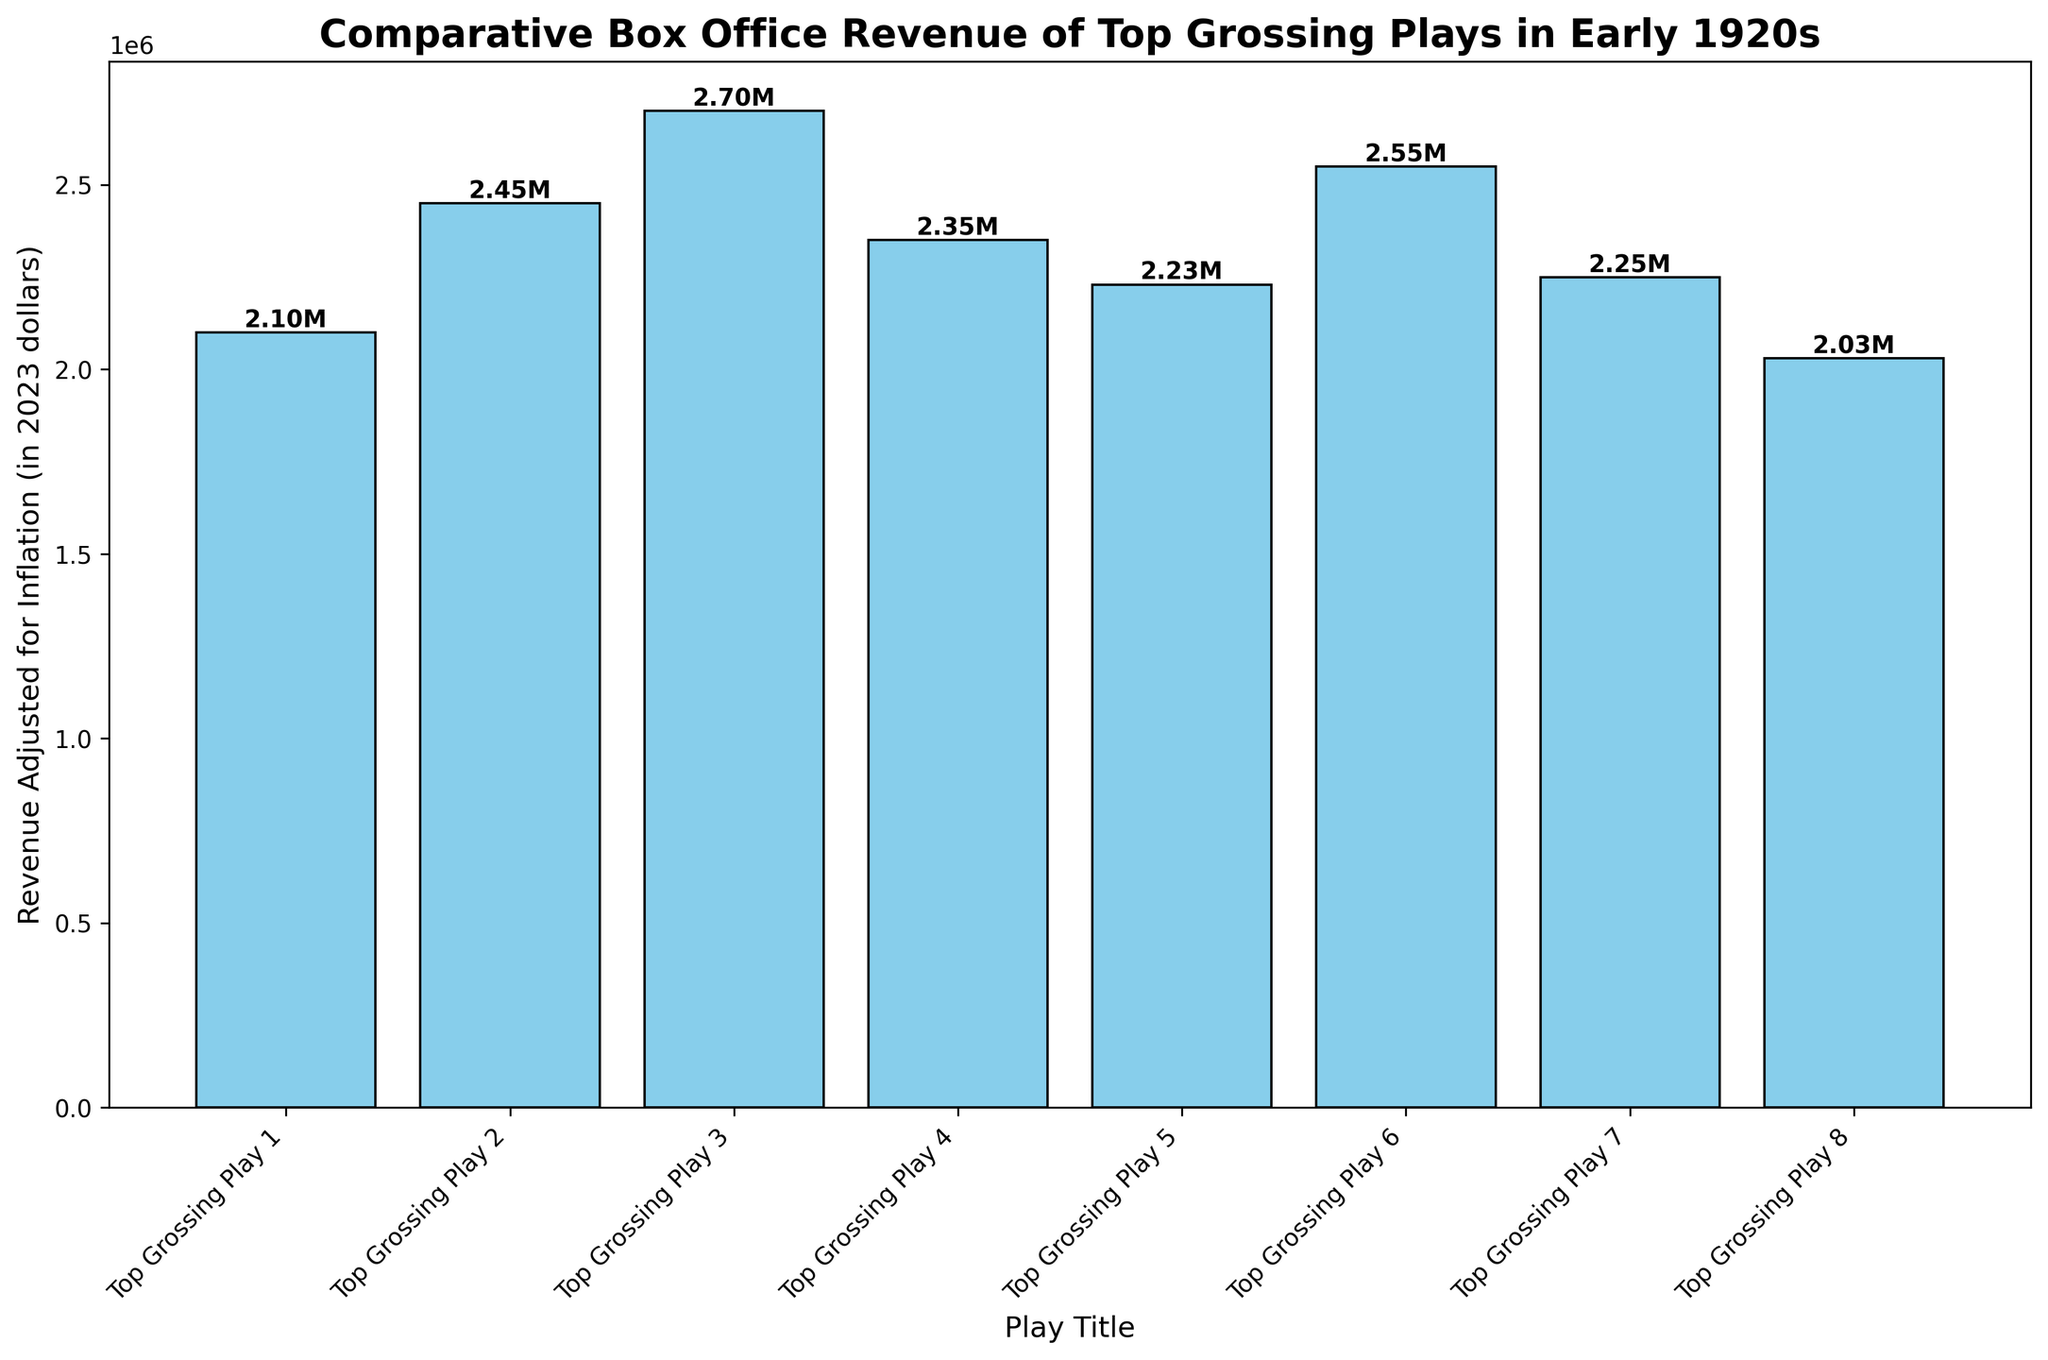What play has the highest adjusted revenue? By looking at the height of the bars, "Name of Play C" in 1923 has the tallest bar, indicating the highest adjusted revenue.
Answer: "Name of Play C" What is the total adjusted revenue of all plays combined? Sum the height values of all bars labeled with text annotations: 2.10M + 2.45M + 2.70M + 2.35M + 2.23M + 2.55M + 2.25M + 2.03M equals 19.66M.
Answer: 19.66M Which play from 1922 had higher adjusted revenue, "Name of Play B" or "Name of Play G"? Compare the heights of the bars for "Name of Play B" and "Name of Play G". "Name of Play B" has a higher bar with 2.45M compared to "Name of Play G" with 2.25M.
Answer: "Name of Play B" What is the average adjusted revenue of the plays in the given data? First, sum the total adjusted revenue of all plays, which is 19.66M, then divide by the number of plays, which is 8: 19.66M / 8 = 2.4575M.
Answer: 2.4575M Which year had the highest number of top-grossing plays? Count the number of bars for each year. 1921 and 1923 both have two plays, which is the highest compared to other years.
Answer: 1921 and 1923 What is the difference in adjusted revenue between "Name of Play A" and "Name of Play H"? Subtract the height value of "Name of Play H" from "Name of Play A" which is 2.10M - 2.03M = 0.07M.
Answer: 0.07M What plays had revenues between 2.0M and 2.4M? Identify the bars with heights between 2.0M and 2.4M: "Name of Play A", "Name of Play E", "Name of Play G", and "Name of Play H".
Answer: "Name of Play A", "Name of Play E", "Name of Play G", "Name of Play H" Which top-grossing play in 1923 had higher revenue? Compare the height of bars for "Name of Play C" and "Name of Play F". "Name of Play C" has a higher bar with 2.70M compared to "Name of Play F" with 2.55M.
Answer: "Name of Play C" How much more revenue did "Name of Play C" generate compared to "Name of Play D"? Subtract the height value of "Name of Play D" from "Name of Play C" which is 2.70M - 2.35M = 0.35M.
Answer: 0.35M 